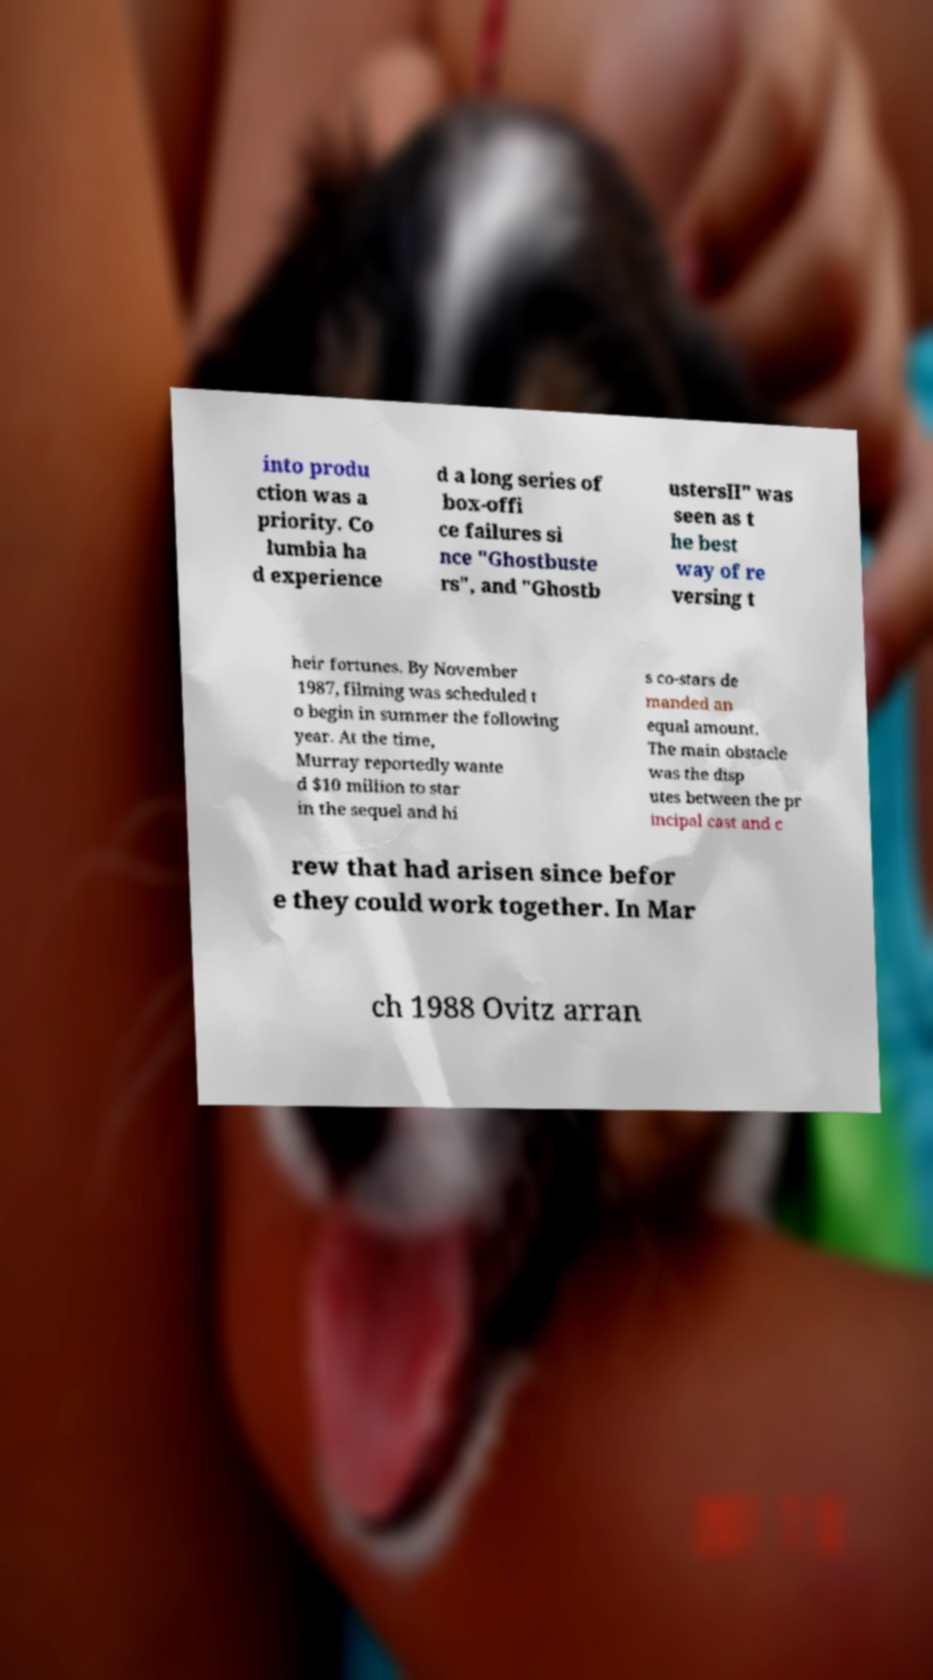There's text embedded in this image that I need extracted. Can you transcribe it verbatim? into produ ction was a priority. Co lumbia ha d experience d a long series of box-offi ce failures si nce "Ghostbuste rs", and "Ghostb ustersII" was seen as t he best way of re versing t heir fortunes. By November 1987, filming was scheduled t o begin in summer the following year. At the time, Murray reportedly wante d $10 million to star in the sequel and hi s co-stars de manded an equal amount. The main obstacle was the disp utes between the pr incipal cast and c rew that had arisen since befor e they could work together. In Mar ch 1988 Ovitz arran 